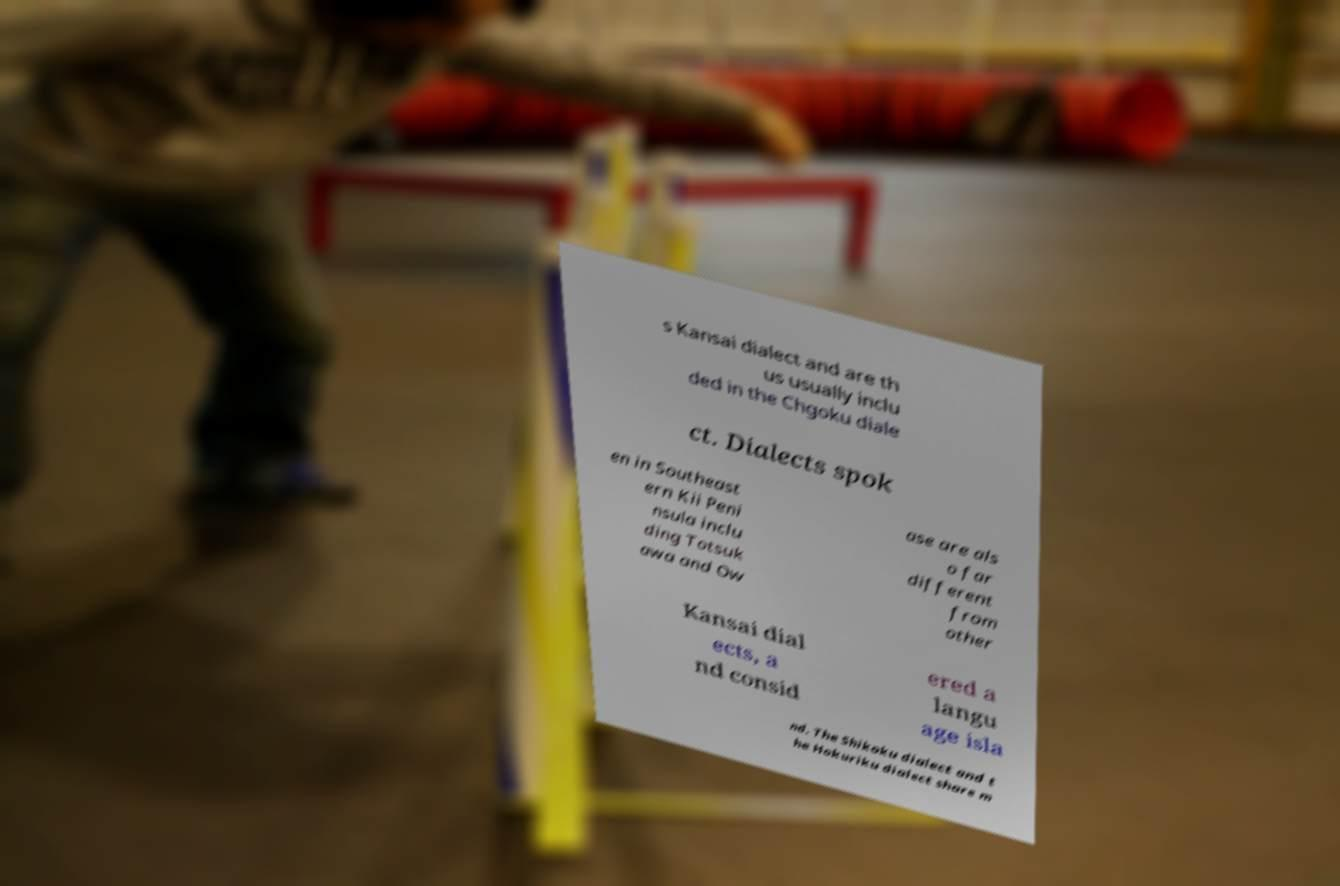Please read and relay the text visible in this image. What does it say? s Kansai dialect and are th us usually inclu ded in the Chgoku diale ct. Dialects spok en in Southeast ern Kii Peni nsula inclu ding Totsuk awa and Ow ase are als o far different from other Kansai dial ects, a nd consid ered a langu age isla nd. The Shikoku dialect and t he Hokuriku dialect share m 